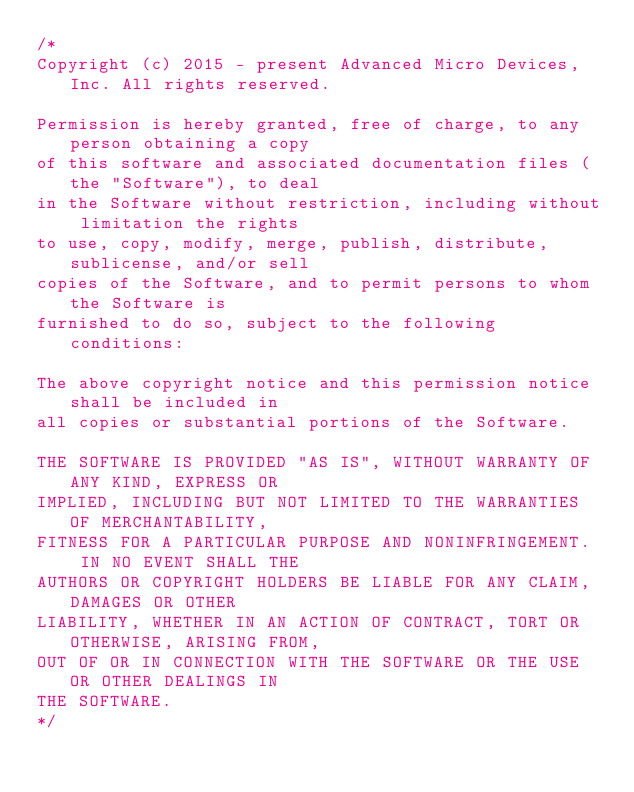Convert code to text. <code><loc_0><loc_0><loc_500><loc_500><_C++_>/*
Copyright (c) 2015 - present Advanced Micro Devices, Inc. All rights reserved.

Permission is hereby granted, free of charge, to any person obtaining a copy
of this software and associated documentation files (the "Software"), to deal
in the Software without restriction, including without limitation the rights
to use, copy, modify, merge, publish, distribute, sublicense, and/or sell
copies of the Software, and to permit persons to whom the Software is
furnished to do so, subject to the following conditions:

The above copyright notice and this permission notice shall be included in
all copies or substantial portions of the Software.

THE SOFTWARE IS PROVIDED "AS IS", WITHOUT WARRANTY OF ANY KIND, EXPRESS OR
IMPLIED, INCLUDING BUT NOT LIMITED TO THE WARRANTIES OF MERCHANTABILITY,
FITNESS FOR A PARTICULAR PURPOSE AND NONINFRINGEMENT.  IN NO EVENT SHALL THE
AUTHORS OR COPYRIGHT HOLDERS BE LIABLE FOR ANY CLAIM, DAMAGES OR OTHER
LIABILITY, WHETHER IN AN ACTION OF CONTRACT, TORT OR OTHERWISE, ARISING FROM,
OUT OF OR IN CONNECTION WITH THE SOFTWARE OR THE USE OR OTHER DEALINGS IN
THE SOFTWARE.
*/
</code> 